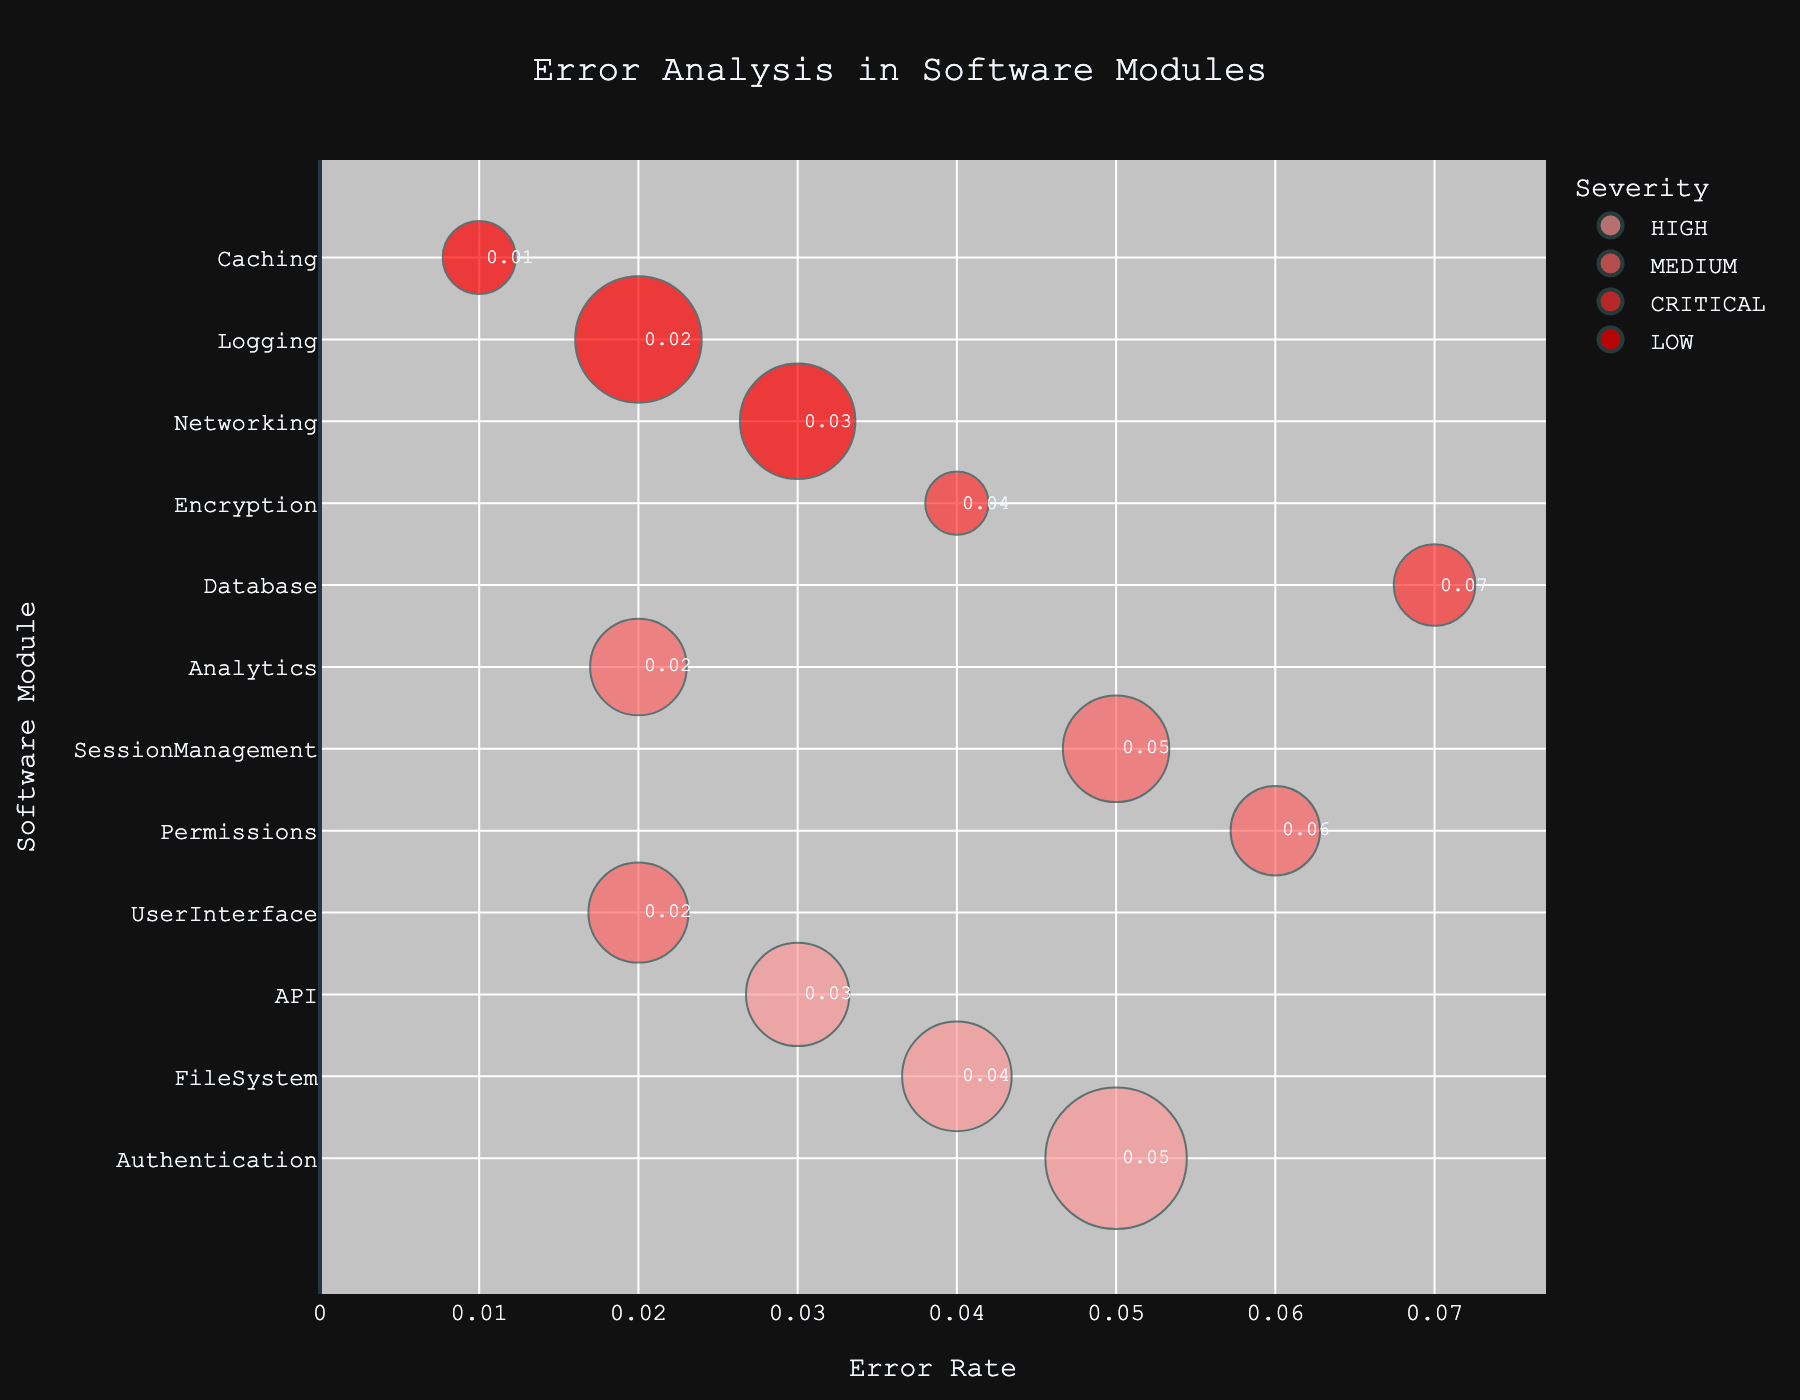what are the highest and lowest error rates shown in the chart? The highest error rate is labeled at 0.07 for the Database module, and the lowest error rate is labeled at 0.01 for the Caching module.
Answer: 0.07 (highest), 0.01 (lowest) Which severity level has the largest bubble, and which module does it correspond to? The largest bubble corresponds to the HIGH severity level for the Authentication module, which has a frequency of 150.
Answer: HIGH, Authentication Which module has a CRITICAL severity level with the highest error rate? The Database module is labeled as having a CRITICAL severity level and its error rate is 0.07, which is the highest among the CRITICAL severity modules.
Answer: Database How many modules have an error rate of 0.02? From the figure, the modules with an error rate of 0.02 are UserInterface, Logging, and Analytics. There are a total of 3 modules with this error rate.
Answer: 3 What is the total frequency of all modules with a MEDIUM severity level? The modules with MEDIUM severity are UserInterface, Permissions, SessionManagement, and Analytics. Their frequencies are 75, 60, 85, and 70, respectively. Adding them gives 75 + 60 + 85 + 70 = 290.
Answer: 290 Which module with a LOW severity level has the highest frequency? The Networking module has a LOW severity level and a frequency of 100, which is the highest among all LOW severity modules.
Answer: Networking If we combine the error rates for modules with MEDIUM severity, what is the resulting value? The modules with MEDIUM severity have error rates of 0.02 (UserInterface), 0.06 (Permissions), 0.05 (SessionManagement), and 0.02 (Analytics). Summing these up gives 0.02 + 0.06 + 0.05 + 0.02 = 0.15.
Answer: 0.15 Which module is located closest to the y-axis? The Caching module, with an error rate of 0.01, is positioned closest to the y-axis on the chart.
Answer: Caching Compare the error rates of the FileSystem and API modules. Which one is higher? The FileSystem module has an error rate of 0.04, while the API module has an error rate of 0.03. Therefore, the error rate of the FileSystem module is higher.
Answer: FileSystem How many modules have an error rate greater than 0.04? The modules with error rates greater than 0.04 are Authentication, Database, Permissions, and SessionManagement. There are 4 modules in total.
Answer: 4 